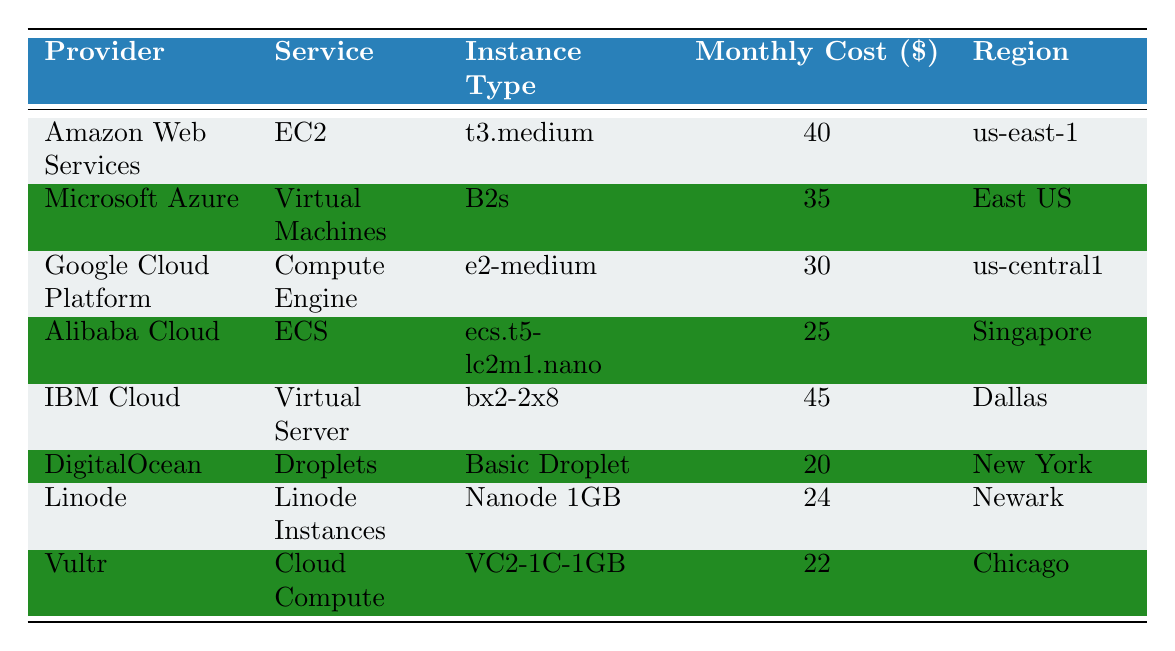Which cloud provider has the lowest monthly cost for web application hosting? By reviewing the monthly cost column, the lowest value is 20, which corresponds to DigitalOcean.
Answer: DigitalOcean What is the monthly cost of the Google Cloud Platform for web application hosting? The monthly cost for Google Cloud Platform is listed in the table as 30.
Answer: 30 Is the monthly cost of Alibaba Cloud more than the monthly cost of Microsoft Azure? Alibaba Cloud has a monthly cost of 25, and Microsoft Azure has a monthly cost of 35. Since 25 is less than 35, the statement is false.
Answer: No What is the total monthly cost for the three cheapest cloud providers? The three cheapest providers based on the monthly cost are DigitalOcean (20), Vultr (22), and Alibaba Cloud (25). Adding these together gives 20 + 22 + 25 = 67.
Answer: 67 Which provider offers the highest monthly cost for a similar workload? The provider with the highest monthly cost listed is IBM Cloud, with a cost of 45.
Answer: IBM Cloud How much less does DigitalOcean cost compared to Amazon Web Services? DigitalOcean costs 20, while Amazon Web Services costs 40. The difference is calculated as 40 - 20 = 20.
Answer: 20 Are the services from Linode more expensive than those from Google Cloud Platform? Linode costs 24, and Google Cloud Platform costs 30. Since 24 is less than 30, the statement is false.
Answer: No What is the average monthly cost of all the cloud providers listed? To find the average, first sum all monthly costs: 40 + 35 + 30 + 25 + 45 + 20 + 24 + 22 = 271. There are 8 providers, so the average is 271 / 8 = 33.875.
Answer: 33.875 How many providers offer monthly costs of 30 or less for web application hosting? The providers offering 30 or less are Google Cloud Platform (30), Alibaba Cloud (25), DigitalOcean (20), Linode (24), and Vultr (22); that's a total of 5 providers.
Answer: 5 